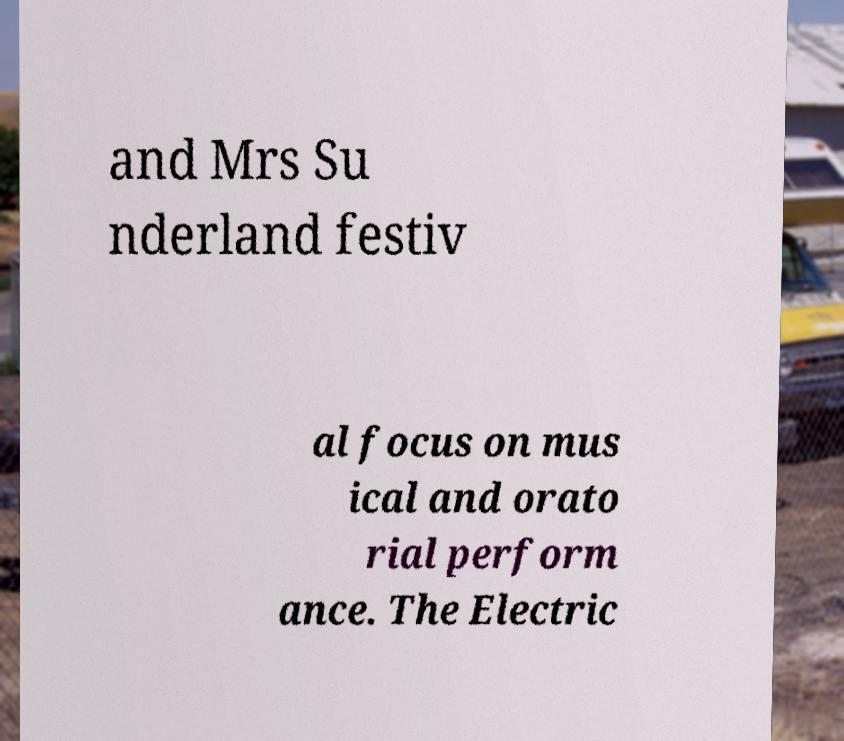Can you accurately transcribe the text from the provided image for me? and Mrs Su nderland festiv al focus on mus ical and orato rial perform ance. The Electric 